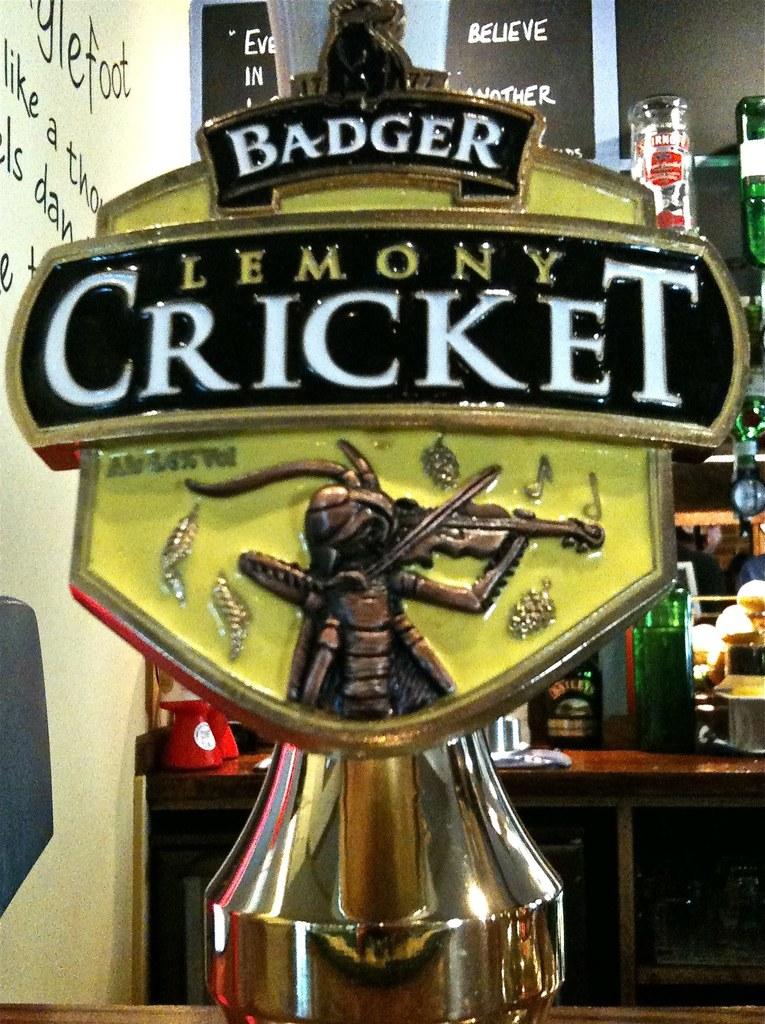Who makes the lemony cricket product?
Provide a succinct answer. Badger. What brand of drink?
Your answer should be compact. Badger. 